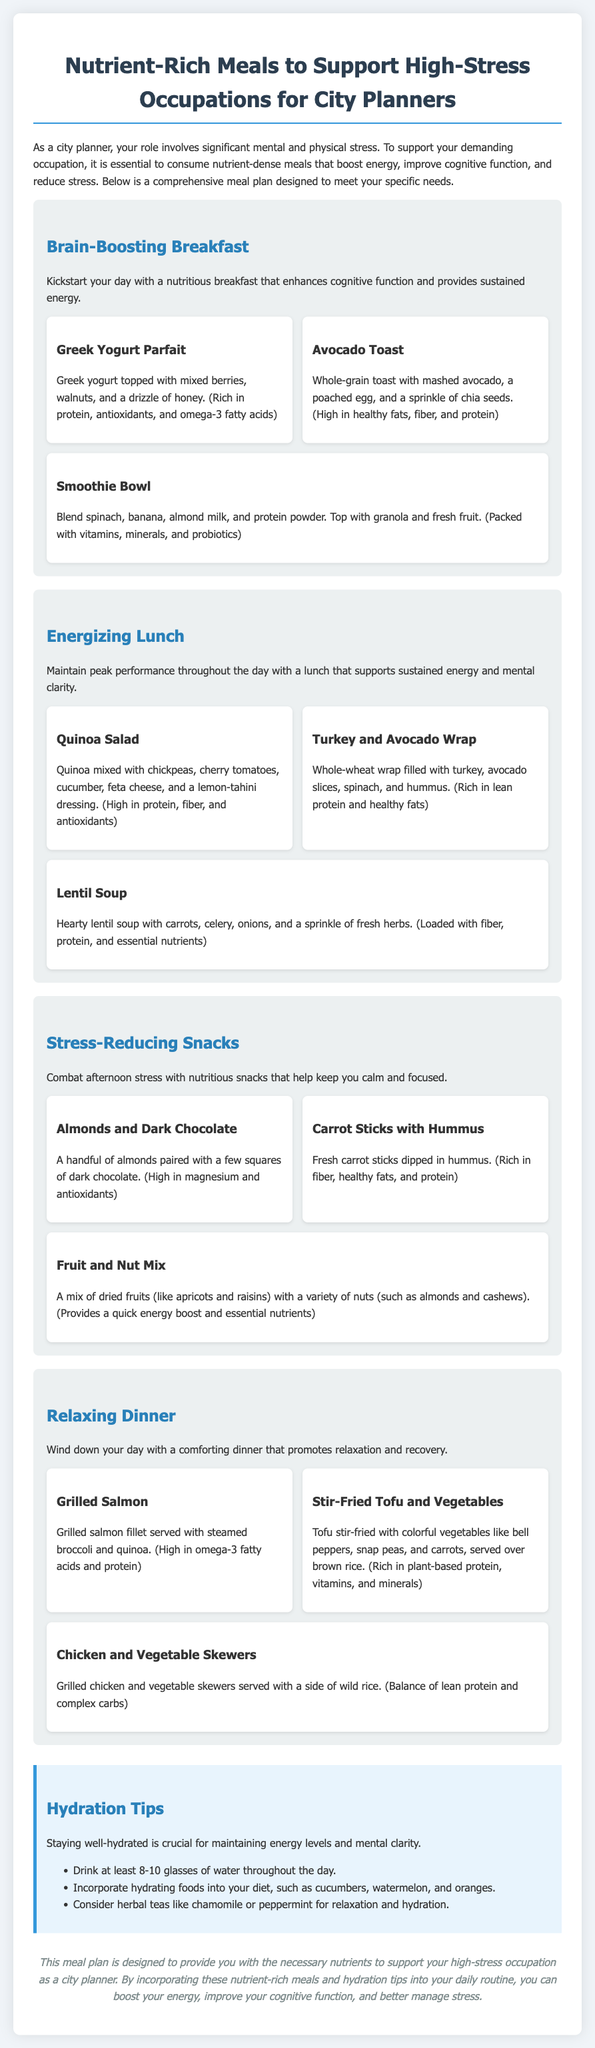What is the title of the document? The title of the document is Nurtient-Rich Meals to Support High-Stress Occupations for City Planners.
Answer: Nutrient-Rich Meals to Support High-Stress Occupations for City Planners How many meals are included in the Brain-Boosting Breakfast section? There are three meals listed in the Brain-Boosting Breakfast section.
Answer: 3 What is one of the ingredients in the Avocado Toast? The Avocado Toast includes mashed avocado.
Answer: mashed avocado Which meal option is high in omega-3 fatty acids and protein? The Grilled Salmon meal option is high in omega-3 fatty acids and protein.
Answer: Grilled Salmon What type of wrap is recommended for lunch? The recommended wrap for lunch is a whole-wheat wrap.
Answer: whole-wheat wrap What is the recommended daily water intake mentioned in the hydration tips? The document suggests drinking at least 8-10 glasses of water throughout the day.
Answer: 8-10 glasses Which nutrient is associated with the snack of Almonds and Dark Chocolate? The snack of Almonds and Dark Chocolate is high in magnesium.
Answer: magnesium How does the meal plan propose to support cognitive function? The meal plan includes nutrient-dense meals that boost energy and improve cognitive function.
Answer: nutrient-dense meals 